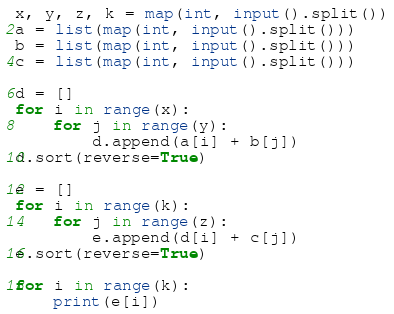Convert code to text. <code><loc_0><loc_0><loc_500><loc_500><_Python_>x, y, z, k = map(int, input().split())
a = list(map(int, input().split()))
b = list(map(int, input().split()))
c = list(map(int, input().split()))

d = []
for i in range(x):
    for j in range(y):
        d.append(a[i] + b[j])
d.sort(reverse=True)

e = []
for i in range(k):
    for j in range(z):
        e.append(d[i] + c[j])
e.sort(reverse=True)

for i in range(k):
    print(e[i])
</code> 